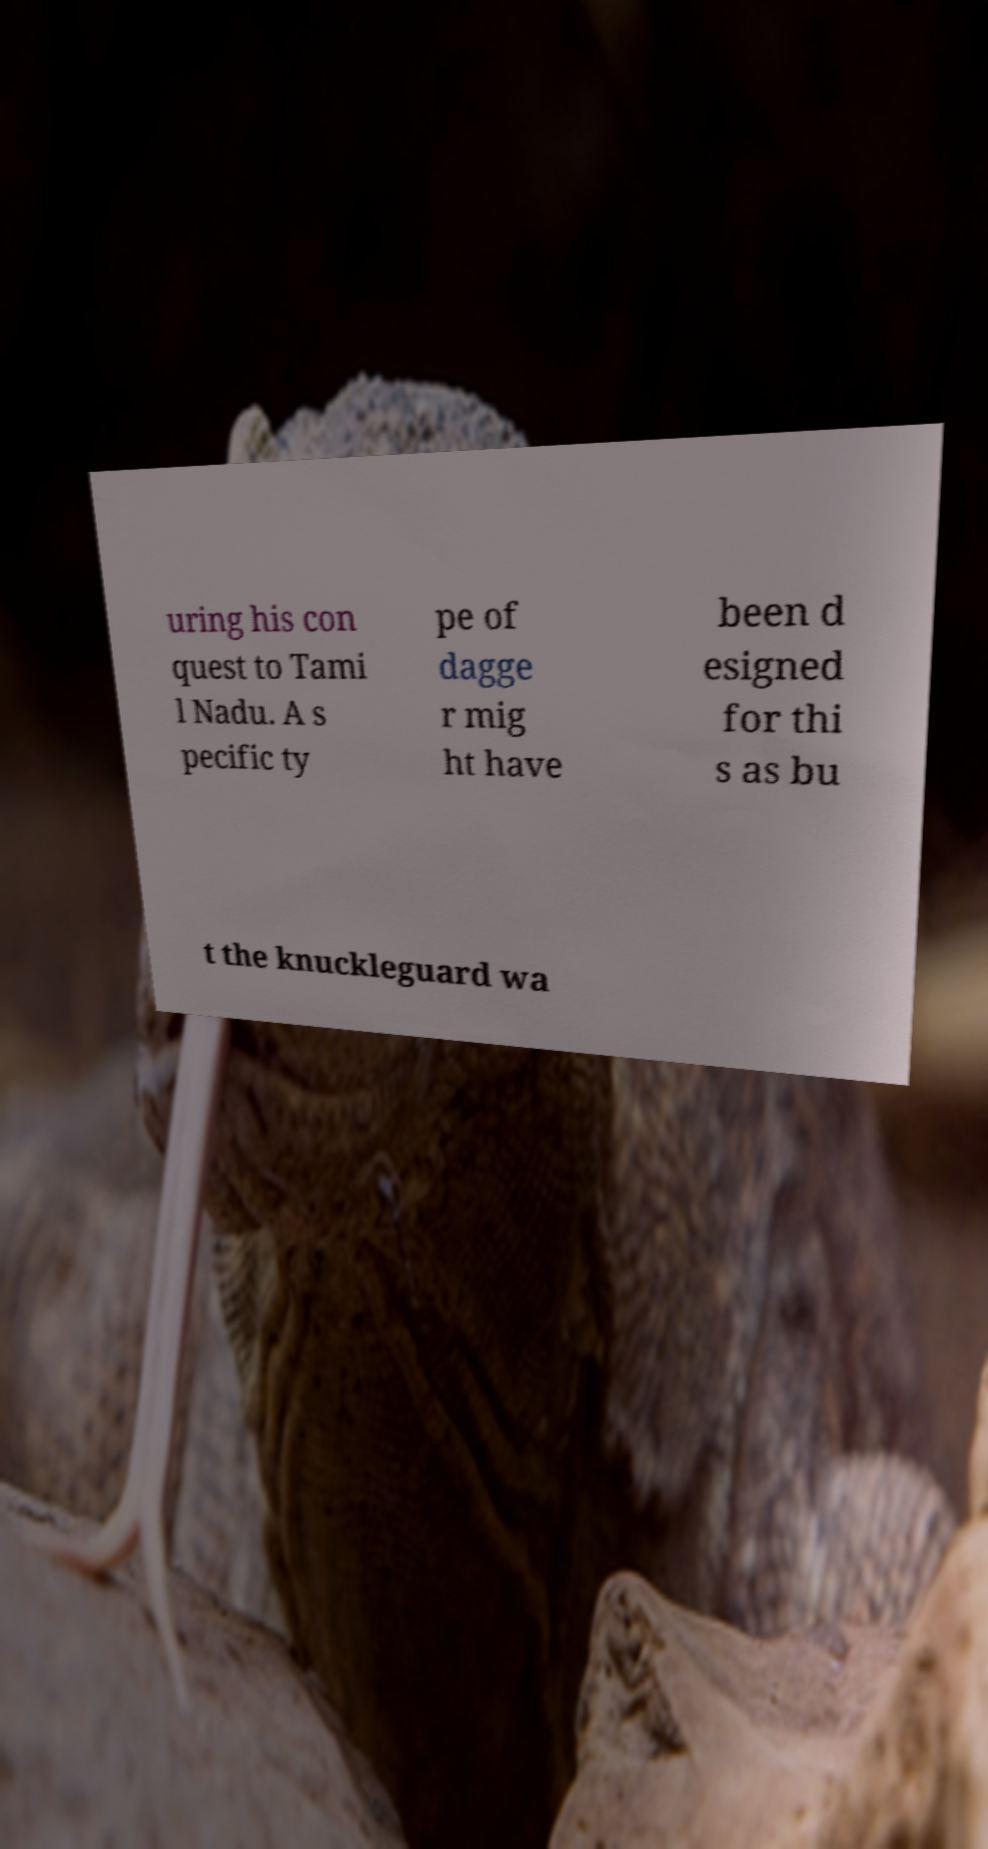Please identify and transcribe the text found in this image. uring his con quest to Tami l Nadu. A s pecific ty pe of dagge r mig ht have been d esigned for thi s as bu t the knuckleguard wa 